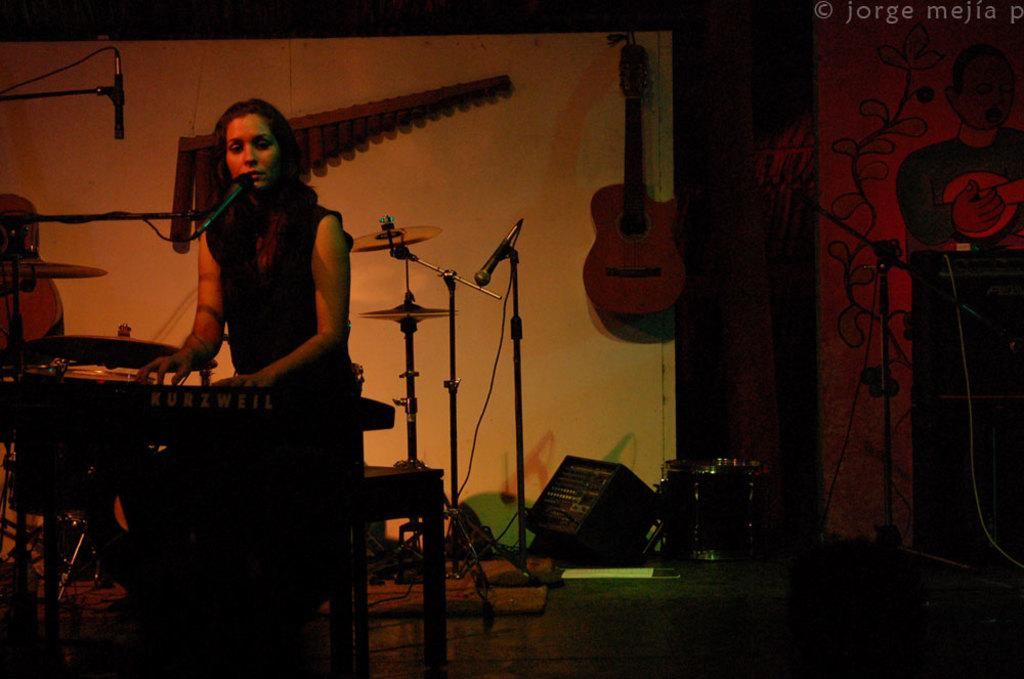What is the man in the image doing? The man is sitting and playing a piano. What object is in front of the man? There is a microphone in front of the man. What can be inferred about the room based on the presence of the microphone? The room might be a music studio or a performance space. What other musical instruments are present in the room? There are many musical instruments in the room. What type of wrench is the man using to adjust the sound of the piano in the image? There is no wrench present in the image, and the man is not adjusting the sound of the piano. 